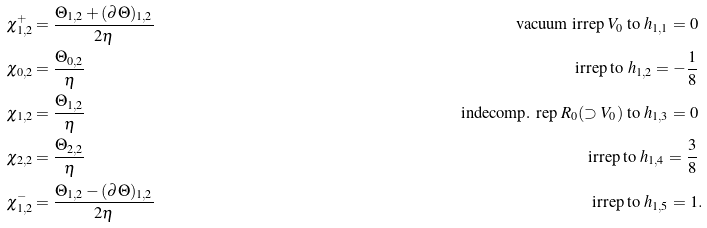<formula> <loc_0><loc_0><loc_500><loc_500>\chi _ { 1 , 2 } ^ { + } & = \frac { \Theta _ { 1 , 2 } + ( \partial \Theta ) _ { 1 , 2 } } { 2 \eta } & { \text { vacuum irrep } V _ { 0 } \text { to } h _ { 1 , 1 } = 0 } \\ \chi _ { 0 , 2 } & = \frac { \Theta _ { 0 , 2 } } { \eta } & { \text { irrep to } h _ { 1 , 2 } = - \frac { 1 } { 8 } } \\ \chi _ { 1 , 2 } & = \frac { \Theta _ { 1 , 2 } } { \eta } & { \text { indecomp. rep } R _ { 0 } ( \supset V _ { 0 } ) \text { to } h _ { 1 , 3 } = 0 } \\ \chi _ { 2 , 2 } & = \frac { \Theta _ { 2 , 2 } } { \eta } & { \text { irrep to } h _ { 1 , 4 } = \frac { 3 } { 8 } } \\ \chi _ { 1 , 2 } ^ { - } & = \frac { \Theta _ { 1 , 2 } - ( \partial \Theta ) _ { 1 , 2 } } { 2 \eta } & { \text { irrep to } h _ { 1 , 5 } = 1 } & .</formula> 